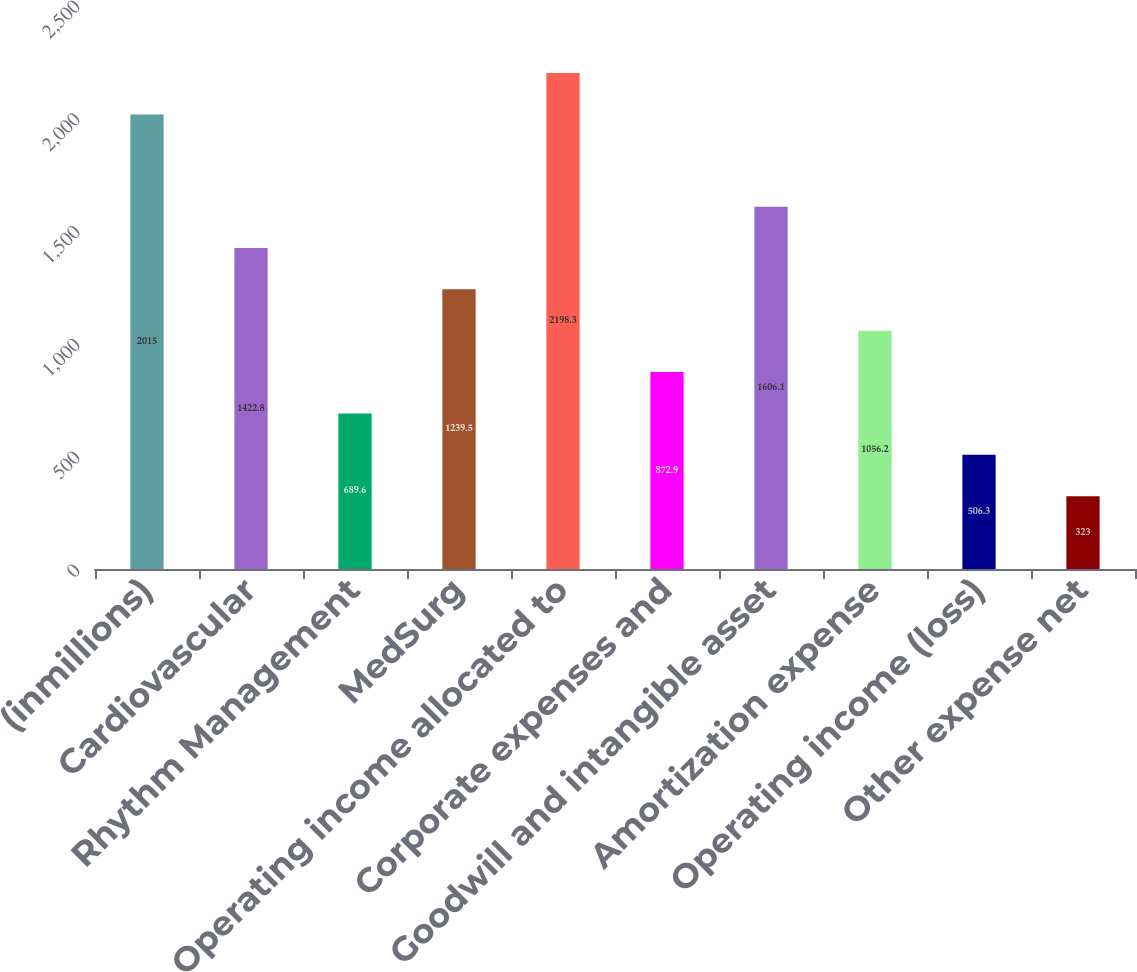Convert chart. <chart><loc_0><loc_0><loc_500><loc_500><bar_chart><fcel>(inmillions)<fcel>Cardiovascular<fcel>Rhythm Management<fcel>MedSurg<fcel>Operating income allocated to<fcel>Corporate expenses and<fcel>Goodwill and intangible asset<fcel>Amortization expense<fcel>Operating income (loss)<fcel>Other expense net<nl><fcel>2015<fcel>1422.8<fcel>689.6<fcel>1239.5<fcel>2198.3<fcel>872.9<fcel>1606.1<fcel>1056.2<fcel>506.3<fcel>323<nl></chart> 